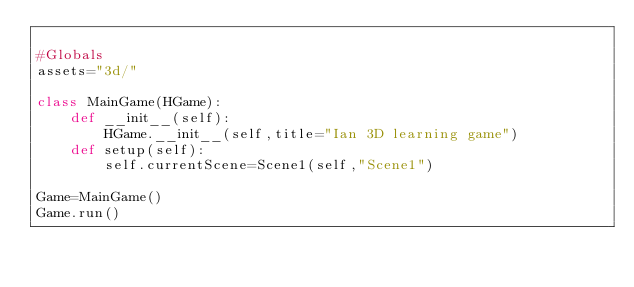<code> <loc_0><loc_0><loc_500><loc_500><_Python_>
#Globals
assets="3d/"

class MainGame(HGame):
    def __init__(self):
        HGame.__init__(self,title="Ian 3D learning game")
    def setup(self):
        self.currentScene=Scene1(self,"Scene1")

Game=MainGame()
Game.run()</code> 